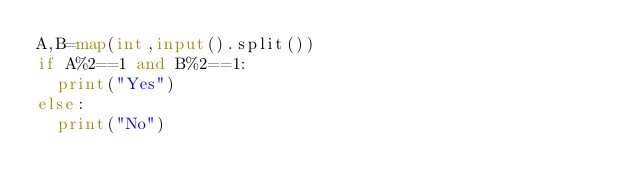<code> <loc_0><loc_0><loc_500><loc_500><_Python_>A,B=map(int,input().split())
if A%2==1 and B%2==1:
  print("Yes")
else:
  print("No")</code> 